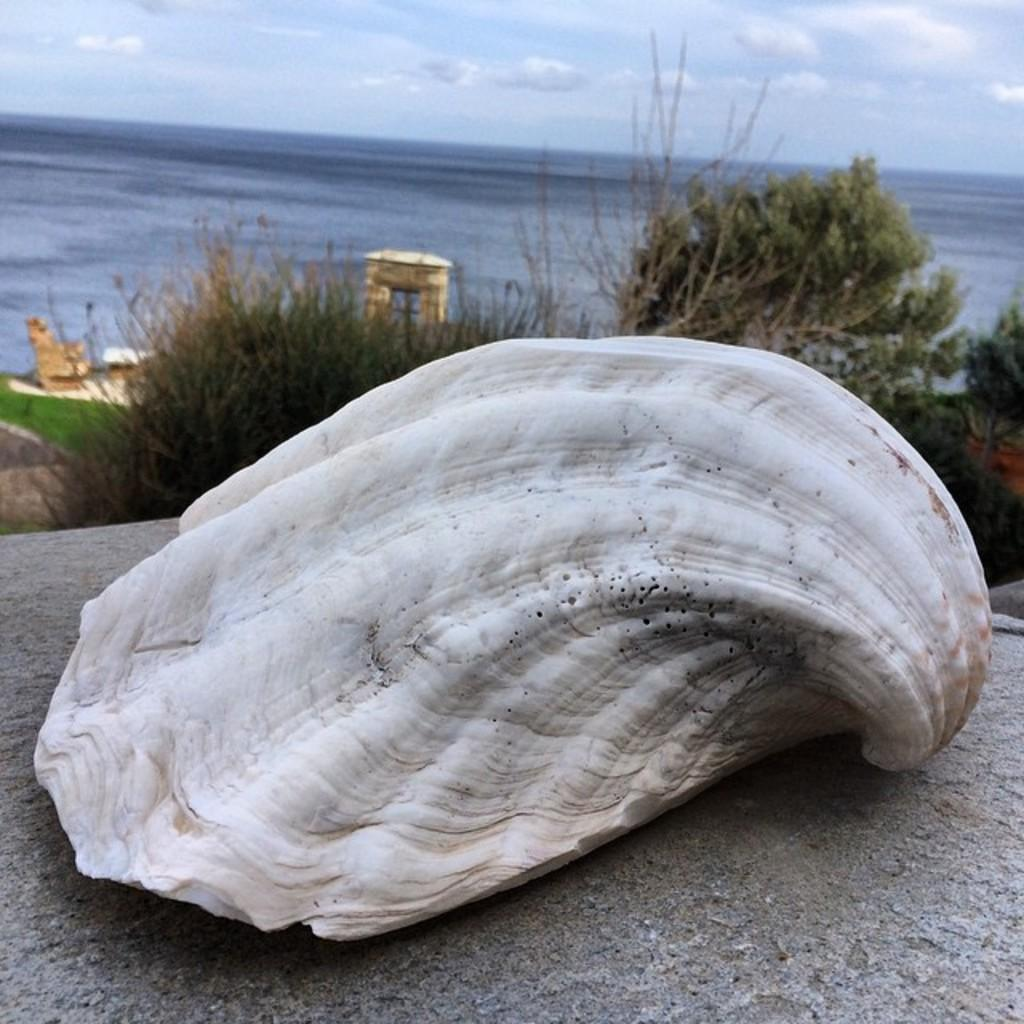What is the main subject in the center of the image? There is a shell in the center of the image. Where is the shell located? The shell is on the ground. What can be seen in the background of the image? Trees, the sea, a building, plants, and the sky are visible in the background of the image. What is the condition of the sky in the image? Clouds are present in the sky. How many cats are sitting on the edge of the shell in the image? There are no cats present in the image, and the shell does not have an edge for them to sit on. 